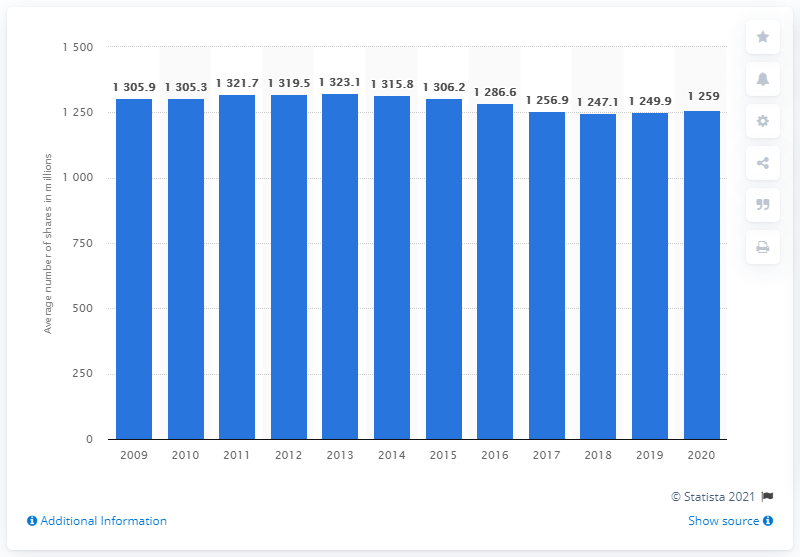Give some essential details in this illustration. Sanofi's average number of shares outstanding in 2020 was approximately 1,259. 